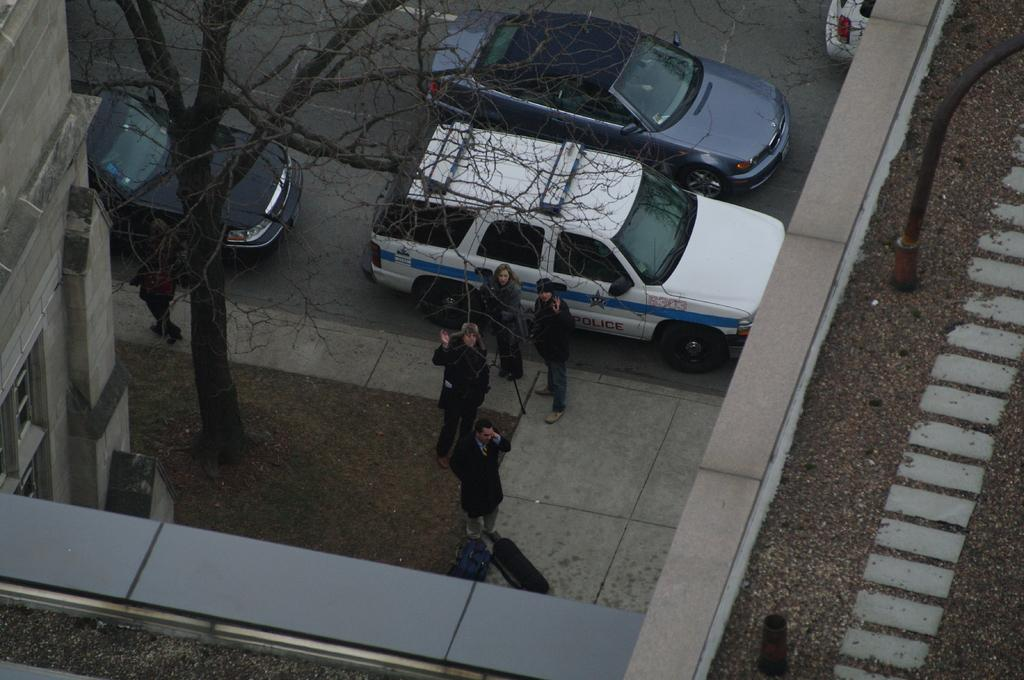How many people are in the foreground of the image? There are five persons in the foreground of the image. Where are the persons located? The persons are on the road. How many cars can be seen in the image? There are four cars in the image. What structures are present at the bottom of the image? There is a building and a tree at the bottom of the image. What is the setting of the image? The image appears to be taken on the road. What is the price of the thing on the sheet in the image? There is no thing on a sheet present in the image. 